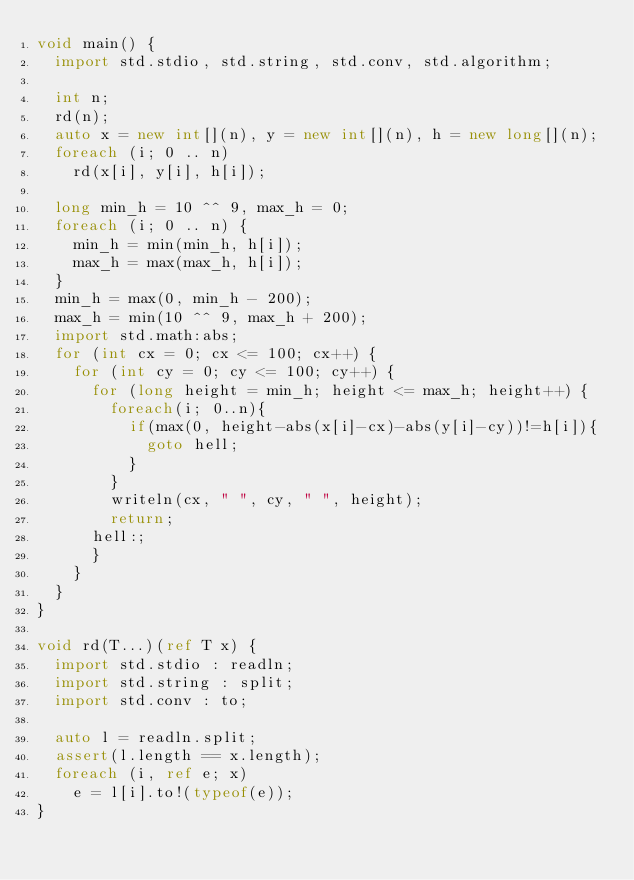Convert code to text. <code><loc_0><loc_0><loc_500><loc_500><_D_>void main() {
  import std.stdio, std.string, std.conv, std.algorithm;

  int n;
  rd(n);
  auto x = new int[](n), y = new int[](n), h = new long[](n);
  foreach (i; 0 .. n)
    rd(x[i], y[i], h[i]);

  long min_h = 10 ^^ 9, max_h = 0;
  foreach (i; 0 .. n) {
    min_h = min(min_h, h[i]);
    max_h = max(max_h, h[i]);
  }
  min_h = max(0, min_h - 200);
  max_h = min(10 ^^ 9, max_h + 200);
  import std.math:abs;
  for (int cx = 0; cx <= 100; cx++) {
    for (int cy = 0; cy <= 100; cy++) {
      for (long height = min_h; height <= max_h; height++) {
        foreach(i; 0..n){
          if(max(0, height-abs(x[i]-cx)-abs(y[i]-cy))!=h[i]){
            goto hell;
          }
        }
        writeln(cx, " ", cy, " ", height);
        return;
      hell:;
      }
    }
  }
}

void rd(T...)(ref T x) {
  import std.stdio : readln;
  import std.string : split;
  import std.conv : to;

  auto l = readln.split;
  assert(l.length == x.length);
  foreach (i, ref e; x)
    e = l[i].to!(typeof(e));
}
</code> 